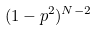Convert formula to latex. <formula><loc_0><loc_0><loc_500><loc_500>( 1 - p ^ { 2 } ) ^ { N - 2 }</formula> 